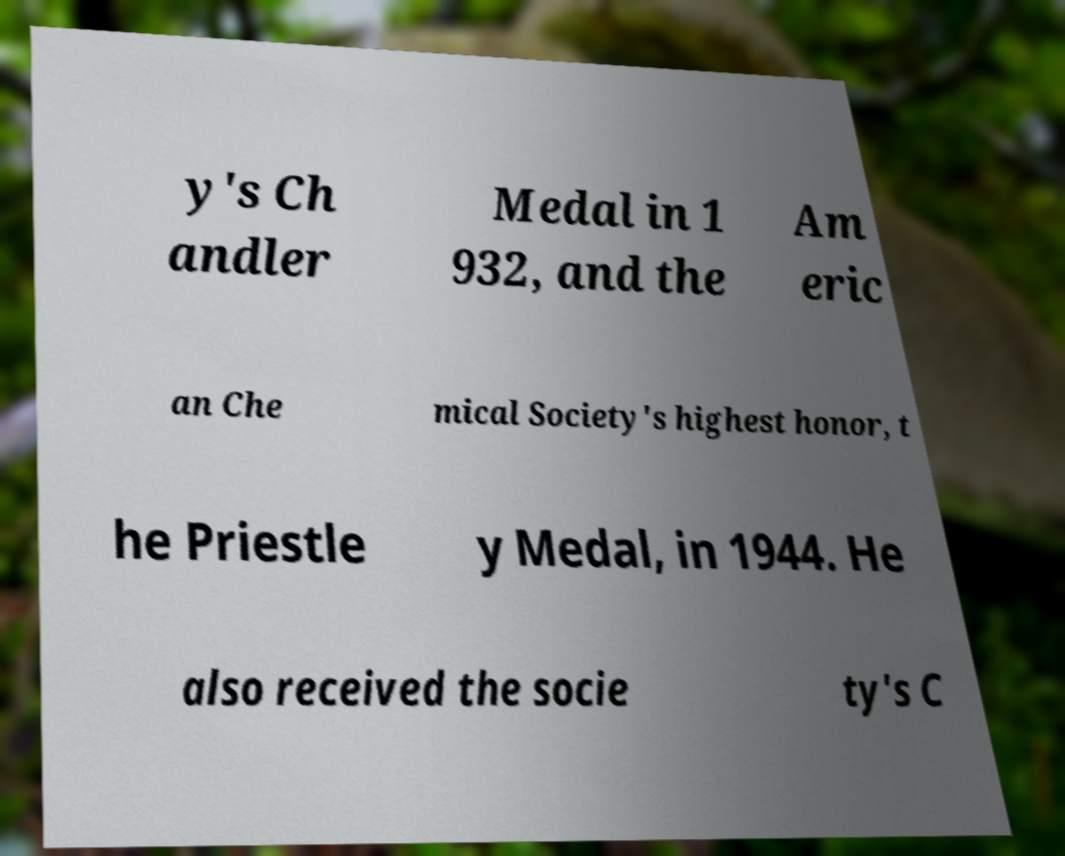Can you accurately transcribe the text from the provided image for me? y's Ch andler Medal in 1 932, and the Am eric an Che mical Society's highest honor, t he Priestle y Medal, in 1944. He also received the socie ty's C 